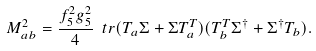<formula> <loc_0><loc_0><loc_500><loc_500>M ^ { 2 } _ { a b } = \frac { f _ { 5 } ^ { 2 } g _ { 5 } ^ { 2 } } { 4 } \ t r ( T _ { a } \Sigma + \Sigma T _ { a } ^ { T } ) ( T _ { b } ^ { T } \Sigma ^ { \dagger } + \Sigma ^ { \dagger } T _ { b } ) .</formula> 